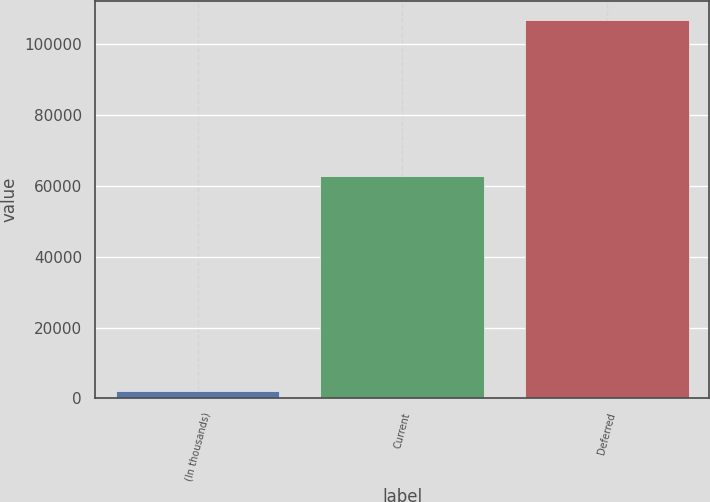<chart> <loc_0><loc_0><loc_500><loc_500><bar_chart><fcel>(In thousands)<fcel>Current<fcel>Deferred<nl><fcel>2011<fcel>62810<fcel>106902<nl></chart> 